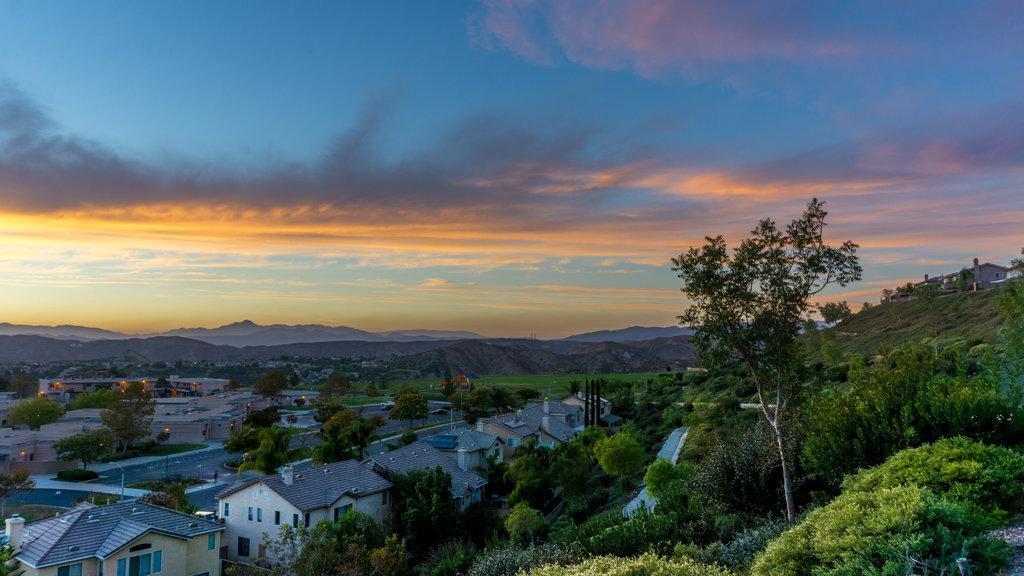Can you describe this image briefly? At the bottom of the image, we can see houses, poles, lights, trees, plants, roads, vehicles, walls and windows. In the background, we can see hills, houses and the sky. 